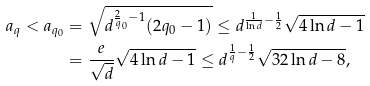Convert formula to latex. <formula><loc_0><loc_0><loc_500><loc_500>a _ { q } < a _ { q _ { 0 } } & = \sqrt { d ^ { \frac { 2 } { q } _ { 0 } - 1 } ( 2 q _ { 0 } - 1 ) } \leq d ^ { \frac { 1 } { \ln d } - \frac { 1 } { 2 } } \sqrt { 4 \ln d - 1 } \\ & = \frac { e } { \sqrt { d } } \sqrt { 4 \ln d - 1 } \leq d ^ { \frac { 1 } { q } - \frac { 1 } { 2 } } \sqrt { 3 2 \ln d - 8 } ,</formula> 